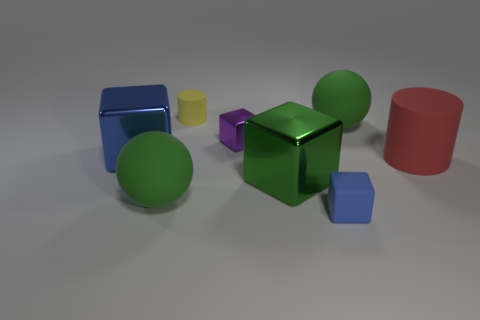There is a blue thing that is to the right of the blue cube behind the green sphere that is to the left of the purple metallic block; what is its size?
Ensure brevity in your answer.  Small. Is the material of the big green sphere that is behind the blue metal cube the same as the small cylinder?
Make the answer very short. Yes. Are there the same number of tiny purple metal blocks that are in front of the small purple shiny block and small yellow objects that are in front of the blue rubber cube?
Your response must be concise. Yes. What is the material of the red object that is the same shape as the yellow rubber thing?
Your answer should be compact. Rubber. Is there a tiny yellow cylinder that is behind the large red rubber cylinder that is in front of the big rubber sphere that is right of the purple shiny object?
Your response must be concise. Yes. Is the shape of the large matte object in front of the large cylinder the same as the small object in front of the big blue object?
Make the answer very short. No. Is the number of small yellow rubber objects behind the small yellow object greater than the number of tiny metal blocks?
Offer a very short reply. No. How many objects are tiny blue rubber blocks or tiny cyan metal blocks?
Offer a very short reply. 1. The small shiny object is what color?
Ensure brevity in your answer.  Purple. How many other objects are there of the same color as the small cylinder?
Provide a short and direct response. 0. 